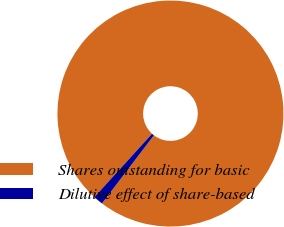<chart> <loc_0><loc_0><loc_500><loc_500><pie_chart><fcel>Shares outstanding for basic<fcel>Dilutive effect of share-based<nl><fcel>98.61%<fcel>1.39%<nl></chart> 